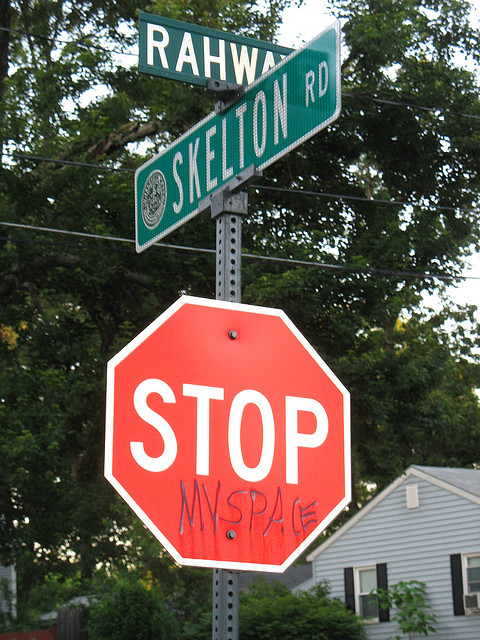Please transcribe the text in this image. RAHW SKELTON RD STOP MYSPACE 